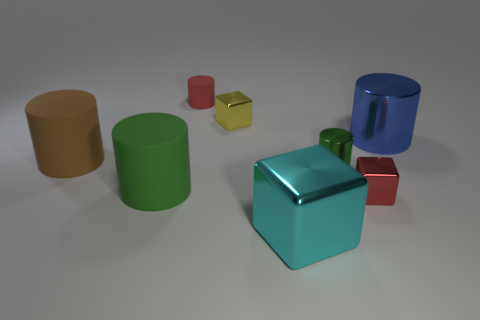How many small shiny things have the same shape as the large cyan object?
Your answer should be compact. 2. There is another cylinder that is the same color as the tiny metal cylinder; what is it made of?
Make the answer very short. Rubber. What is the shape of the green thing that is made of the same material as the large blue object?
Ensure brevity in your answer.  Cylinder. Are there any other rubber objects that have the same shape as the big green matte object?
Provide a short and direct response. Yes. What shape is the metallic object that is in front of the large green matte cylinder and to the right of the cyan shiny block?
Provide a succinct answer. Cube. What size is the shiny cylinder that is behind the large brown cylinder?
Offer a terse response. Large. Is the number of green things behind the green matte object less than the number of shiny blocks in front of the tiny yellow metallic thing?
Keep it short and to the point. Yes. What is the size of the metal thing that is in front of the small yellow metallic cube and behind the green shiny cylinder?
Ensure brevity in your answer.  Large. Are there any tiny cylinders left of the large metal object on the left side of the big blue metal cylinder in front of the small red matte cylinder?
Ensure brevity in your answer.  Yes. Is there a tiny yellow shiny block?
Provide a succinct answer. Yes. 